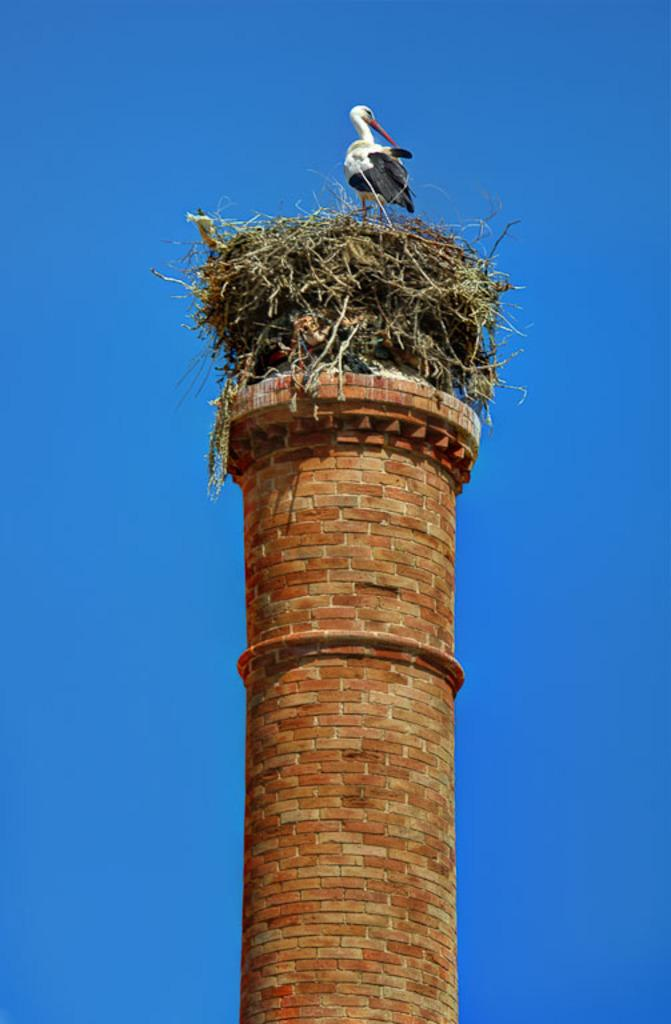What type of animal can be seen in the image? There is a bird in the image. Where is the bird located? The bird is on the grass. What is the grass situated on? The grass is on a tower. What can be seen in the background of the image? There is sky visible in the background of the image. What type of line can be seen in the aftermath of the bird's actions in the image? There is no line or aftermath of the bird's actions present in the image. 